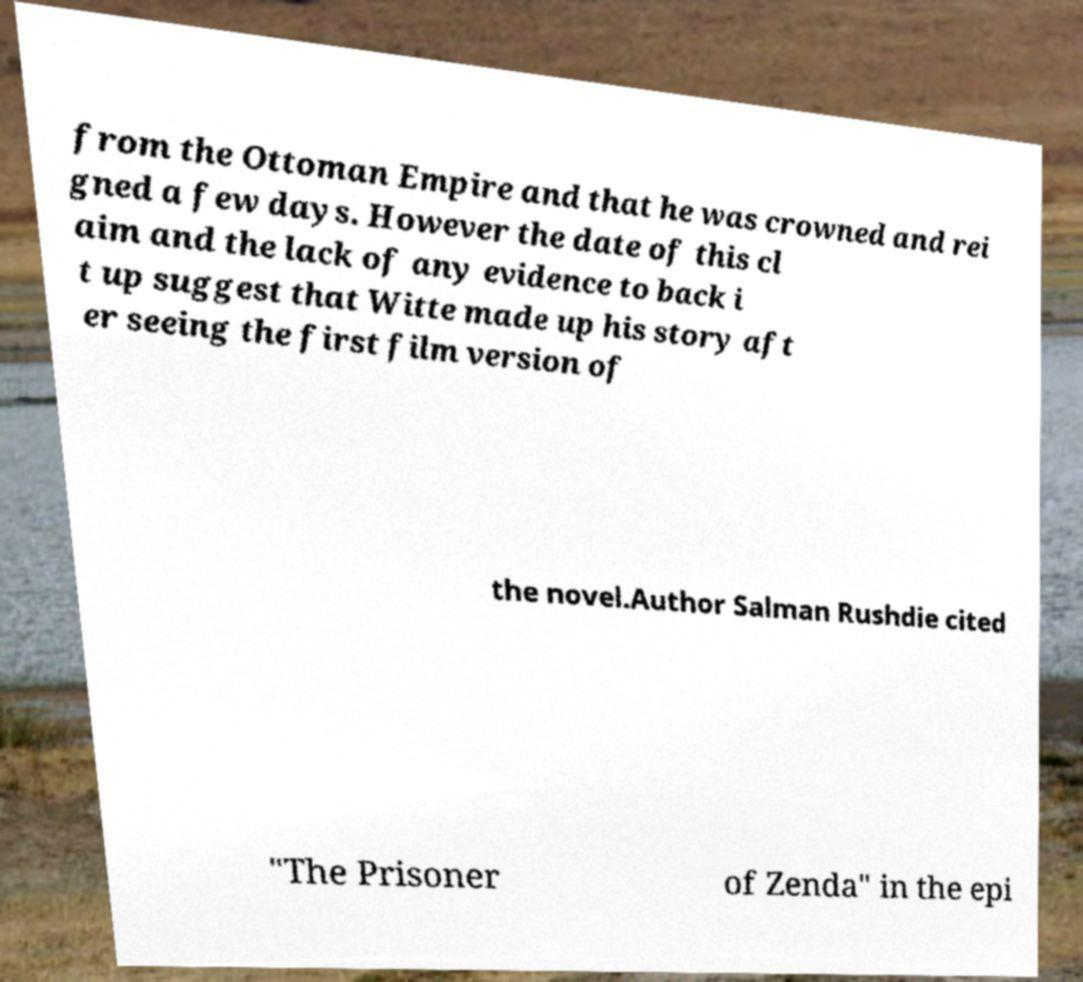For documentation purposes, I need the text within this image transcribed. Could you provide that? from the Ottoman Empire and that he was crowned and rei gned a few days. However the date of this cl aim and the lack of any evidence to back i t up suggest that Witte made up his story aft er seeing the first film version of the novel.Author Salman Rushdie cited "The Prisoner of Zenda" in the epi 